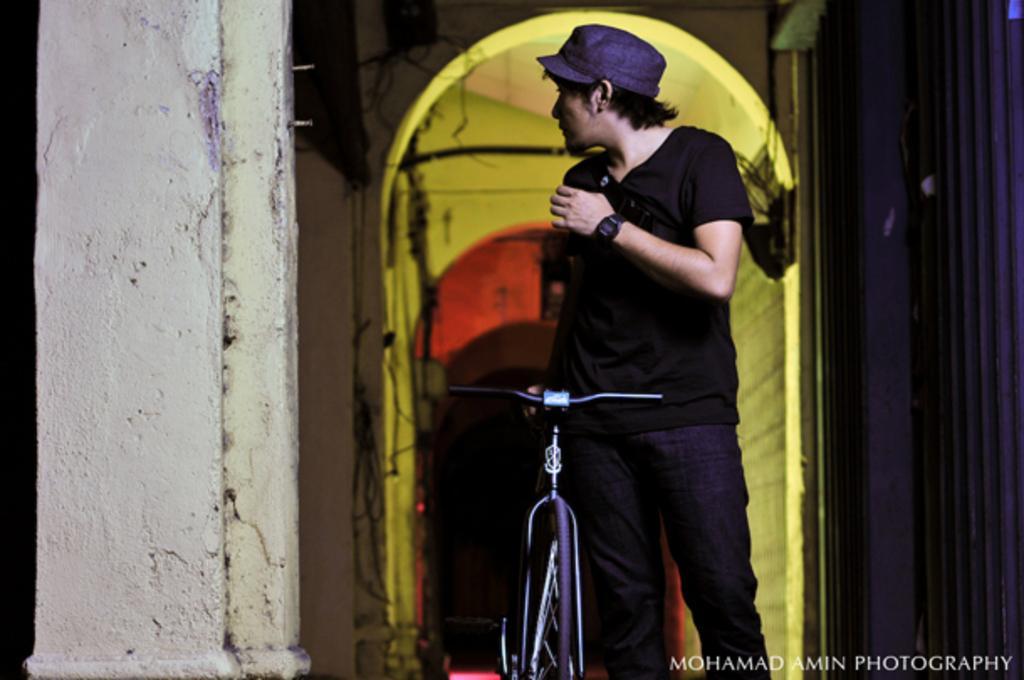Please provide a concise description of this image. In this image I can see a person standing with bicycle. There are walls , cables and water mark on the bottom of the image. 